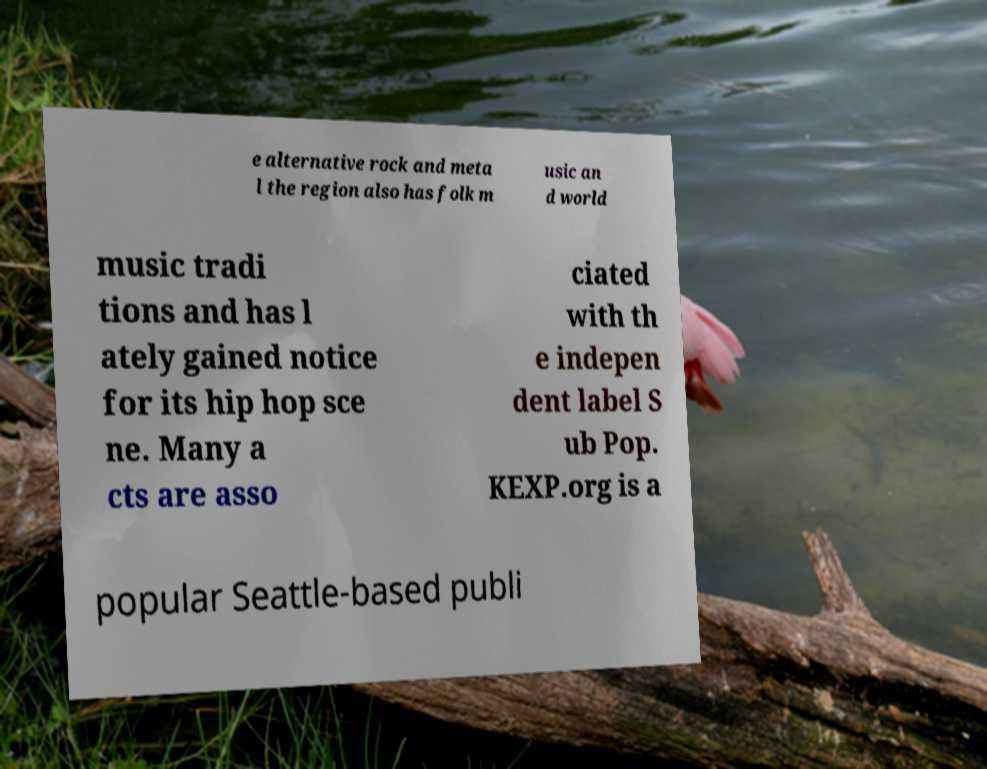I need the written content from this picture converted into text. Can you do that? e alternative rock and meta l the region also has folk m usic an d world music tradi tions and has l ately gained notice for its hip hop sce ne. Many a cts are asso ciated with th e indepen dent label S ub Pop. KEXP.org is a popular Seattle-based publi 